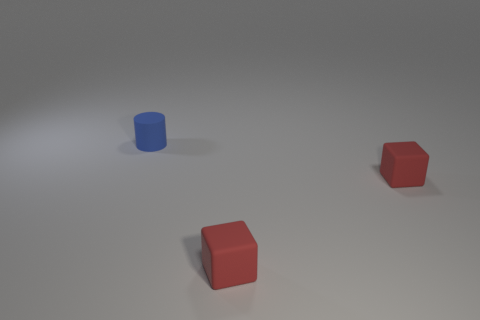Add 2 tiny green rubber spheres. How many objects exist? 5 Subtract all cylinders. How many objects are left? 2 Subtract all big yellow metal cylinders. Subtract all red things. How many objects are left? 1 Add 2 blue cylinders. How many blue cylinders are left? 3 Add 1 cubes. How many cubes exist? 3 Subtract 0 green blocks. How many objects are left? 3 